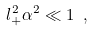Convert formula to latex. <formula><loc_0><loc_0><loc_500><loc_500>l _ { + } ^ { 2 } \alpha ^ { 2 } \ll 1 \ ,</formula> 